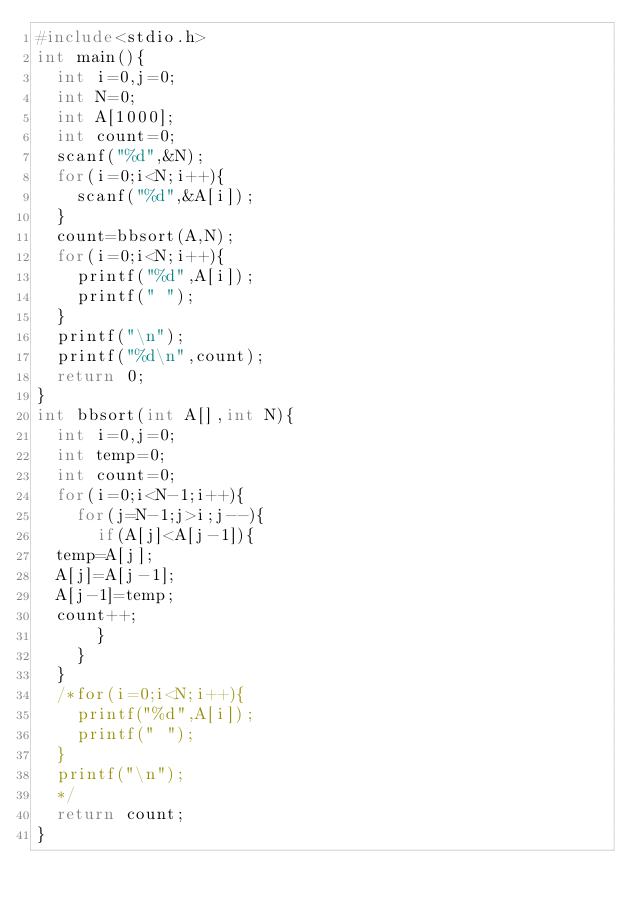<code> <loc_0><loc_0><loc_500><loc_500><_C_>#include<stdio.h>
int main(){
  int i=0,j=0;
  int N=0;
  int A[1000];
  int count=0;
  scanf("%d",&N);
  for(i=0;i<N;i++){
    scanf("%d",&A[i]);
  }
  count=bbsort(A,N);
  for(i=0;i<N;i++){
    printf("%d",A[i]);
    printf(" ");
  }
  printf("\n");
  printf("%d\n",count);
  return 0;
}
int bbsort(int A[],int N){
  int i=0,j=0;
  int temp=0;
  int count=0;
  for(i=0;i<N-1;i++){
    for(j=N-1;j>i;j--){
      if(A[j]<A[j-1]){
	temp=A[j];
	A[j]=A[j-1];
	A[j-1]=temp;
	count++;
      }
    }
  }
  /*for(i=0;i<N;i++){
    printf("%d",A[i]);
    printf(" ");
  }
  printf("\n");
  */
  return count;
}

</code> 